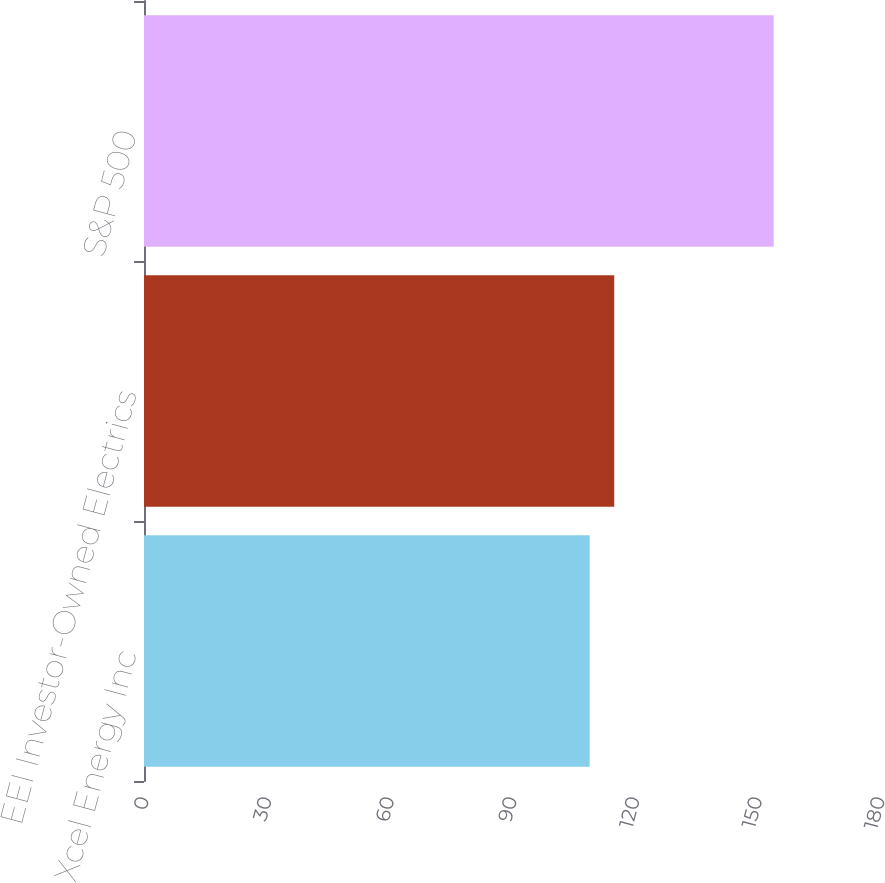<chart> <loc_0><loc_0><loc_500><loc_500><bar_chart><fcel>Xcel Energy Inc<fcel>EEI Investor-Owned Electrics<fcel>S&P 500<nl><fcel>109<fcel>115<fcel>154<nl></chart> 